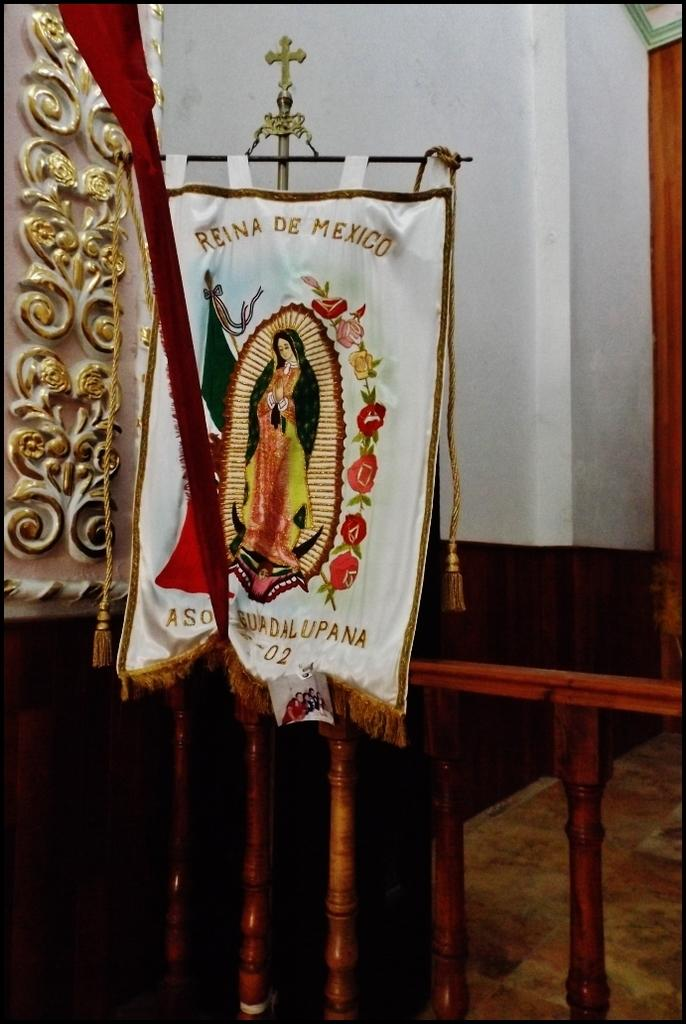What material is present in the image? There is cloth in the image. Who or what can be seen in the image? There is a person in the image. What decorative elements are on the cloth? There are flowers on the cloth. What architectural feature is visible in the image? There is a railing in the image. What can be seen in the background of the image? There is a wall in the background of the image. What religious symbol can be seen on the cloth in the image? There is no religious symbol present on the cloth in the image. How deep are the roots of the flowers on the cloth? There are no roots visible on the flowers in the image, as they are decorative elements on the cloth. 